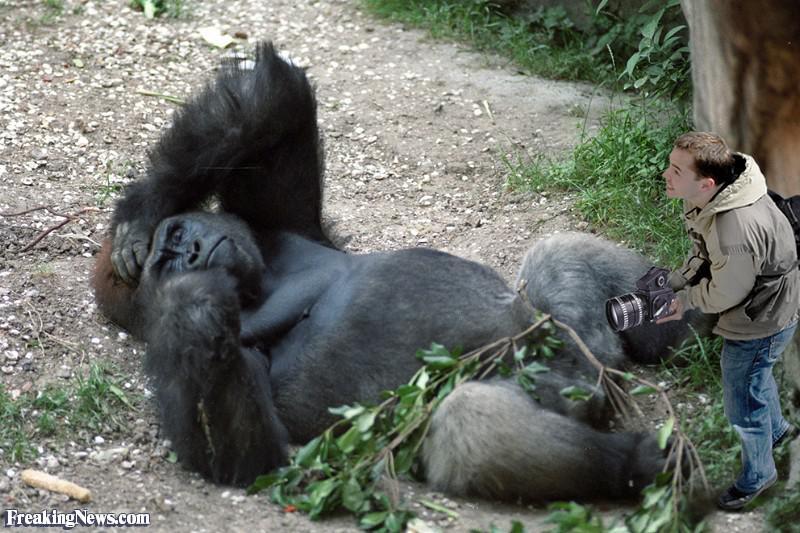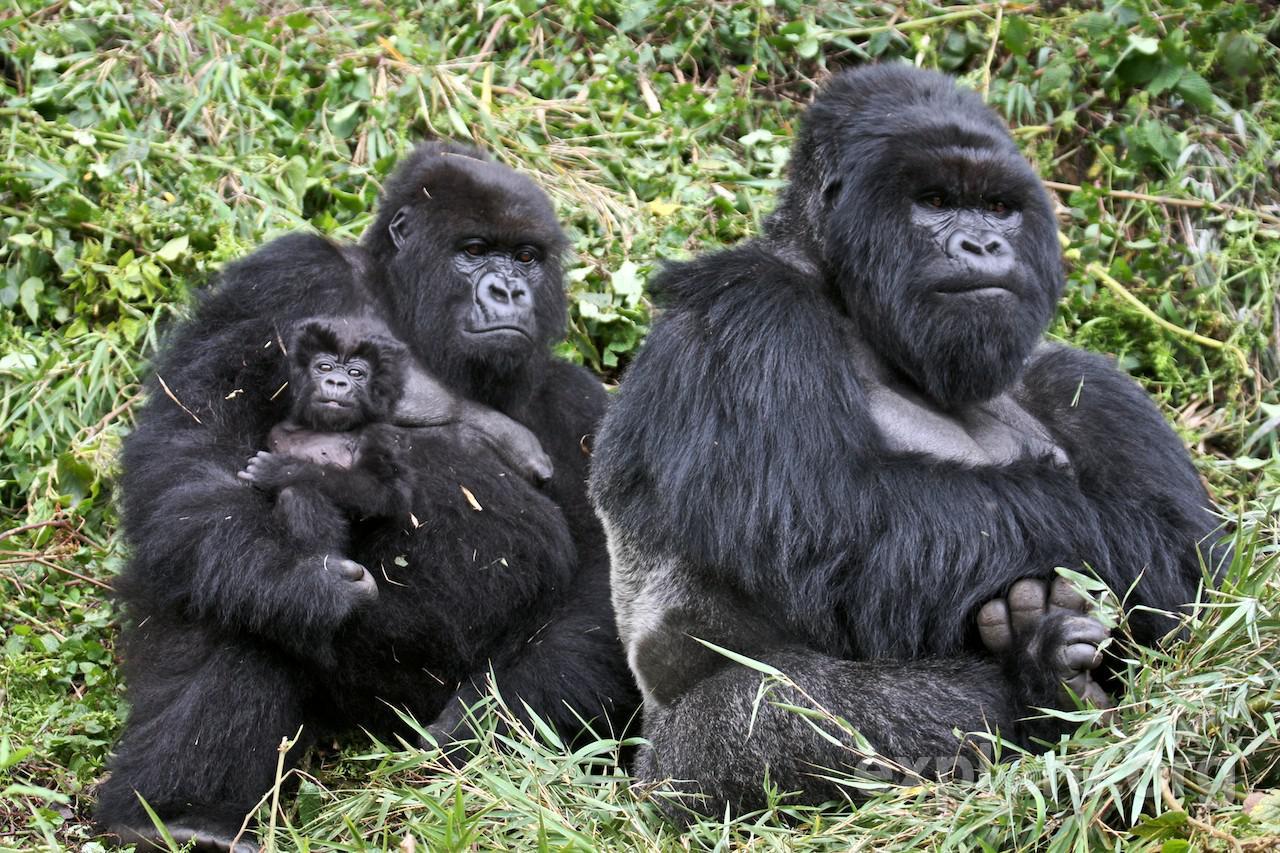The first image is the image on the left, the second image is the image on the right. Evaluate the accuracy of this statement regarding the images: "An image shows a baby gorilla held in its mother's arms.". Is it true? Answer yes or no. Yes. The first image is the image on the left, the second image is the image on the right. Considering the images on both sides, is "A gorilla is holding a baby in one of the images." valid? Answer yes or no. Yes. 